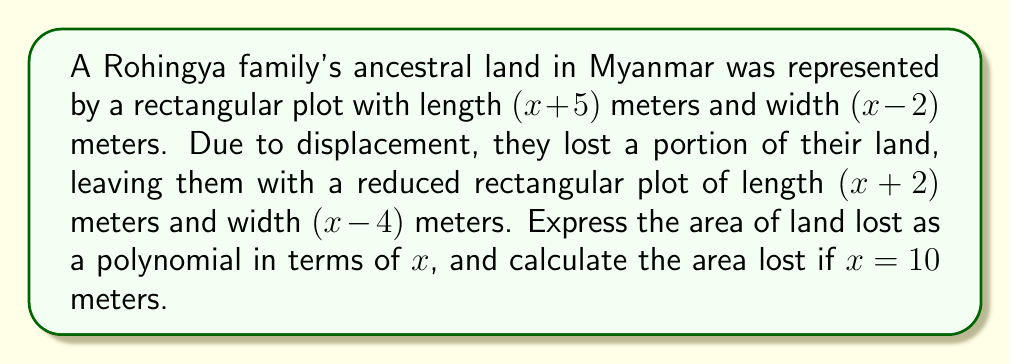Solve this math problem. 1) First, let's find the original area:
   Original area = $(x+5)(x-2)$ 
   $$ = x^2 + 5x - 2x - 10 = x^2 + 3x - 10 $$

2) Now, let's find the new reduced area:
   New area = $(x+2)(x-4)$
   $$ = x^2 + 2x - 4x - 8 = x^2 - 2x - 8 $$

3) The area lost is the difference between the original and new areas:
   Area lost = Original area - New area
   $$ = (x^2 + 3x - 10) - (x^2 - 2x - 8) $$
   $$ = x^2 + 3x - 10 - x^2 + 2x + 8 $$
   $$ = 5x - 2 $$

4) To find the area lost when $x = 10$, we substitute:
   Area lost = $5(10) - 2 = 50 - 2 = 48$

Therefore, the area lost is $5x - 2$ square meters, and when $x = 10$, the area lost is 48 square meters.
Answer: $5x - 2$ sq m; 48 sq m when $x=10$ 